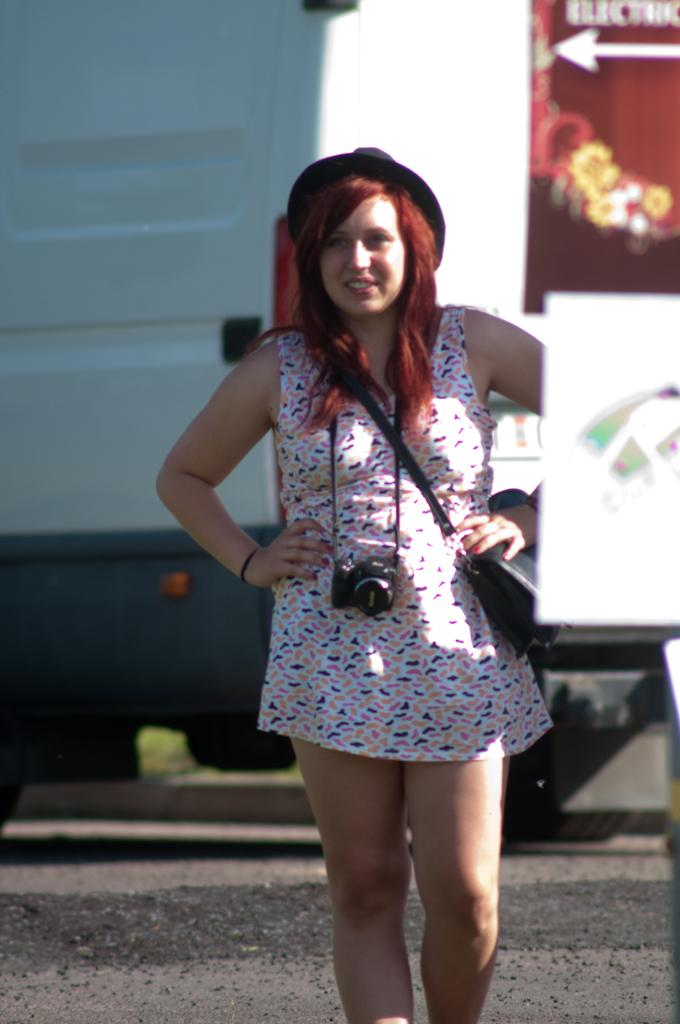Who is the main subject in the image? There is a woman in the image. What is the woman wearing? The woman is wearing a camera. What else is the woman carrying? The woman is carrying a bag. Where is the woman standing? The woman is standing on a road. Can you describe the background of the image? The background of the image is blurred. What type of bean is being recited in a verse in the image? There is no bean or verse present in the image; it features a woman wearing a camera and standing on a road. Can you tell me where the vase is located in the image? There is no vase present in the image. 